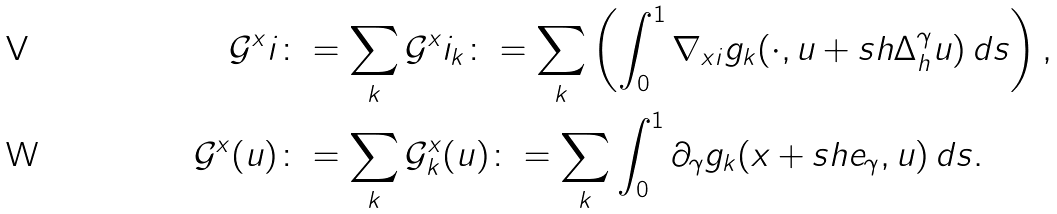Convert formula to latex. <formula><loc_0><loc_0><loc_500><loc_500>\mathcal { G } ^ { x } i & \colon = \sum _ { k } \mathcal { G } ^ { x } i _ { k } \colon = \sum _ { k } \left ( \int _ { 0 } ^ { 1 } \nabla _ { x i } g _ { k } ( \cdot , u + s h \Delta _ { h } ^ { \gamma } u ) \, d s \right ) , \\ \mathcal { G } ^ { x } ( u ) & \colon = \sum _ { k } \mathcal { G } ^ { x } _ { k } ( u ) \colon = \sum _ { k } \int _ { 0 } ^ { 1 } \partial _ { \gamma } g _ { k } ( x + s h e _ { \gamma } , u ) \, d s .</formula> 